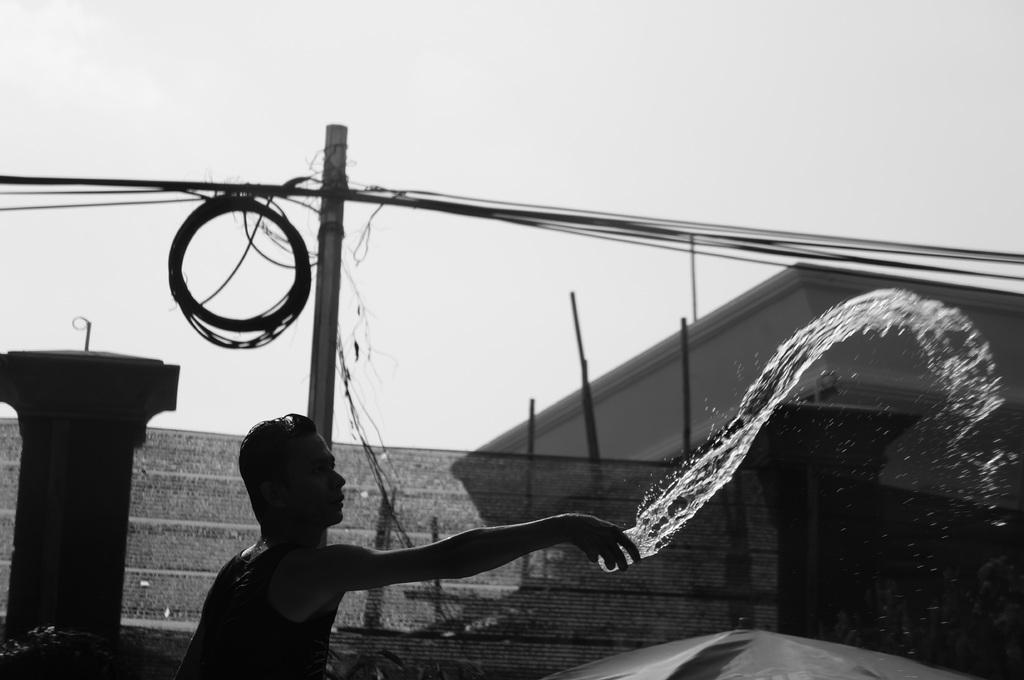What is the man in the image doing? The man is standing and throwing water from a glass. What can be seen at the right side of the image? There is a house at the right side of the image. What is present in the image that is related to electricity or communication? There is a pole in the image, and many cables are connected to it. What type of gate is blocking the entrance to the house in the image? There is no gate blocking the entrance to the house in the image; it is not mentioned in the provided facts. What disease is the man trying to cure by throwing water from a glass? There is no indication of a disease or any medical context in the image, so it cannot be determined from the picture. 